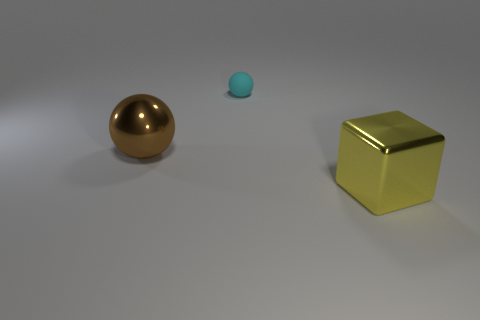Is there anything else that has the same material as the small cyan thing?
Provide a succinct answer. No. What is the size of the object that is the same material as the cube?
Provide a succinct answer. Large. How many big things are rubber balls or green cubes?
Your answer should be very brief. 0. Are there any large green spheres that have the same material as the big brown thing?
Offer a very short reply. No. There is a big thing to the right of the brown metal sphere; what is its material?
Offer a terse response. Metal. There is another object that is the same size as the yellow object; what color is it?
Make the answer very short. Brown. How many other things are the same shape as the yellow metallic object?
Provide a succinct answer. 0. There is a sphere in front of the cyan sphere; what size is it?
Provide a short and direct response. Large. There is a large object that is in front of the big brown metallic thing; what number of large balls are on the right side of it?
Offer a very short reply. 0. How many other things are there of the same size as the yellow metallic cube?
Your response must be concise. 1. 